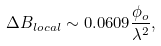Convert formula to latex. <formula><loc_0><loc_0><loc_500><loc_500>\Delta B _ { l o c a l } \sim 0 . 0 6 0 9 \frac { \phi _ { o } } { \lambda ^ { 2 } } ,</formula> 